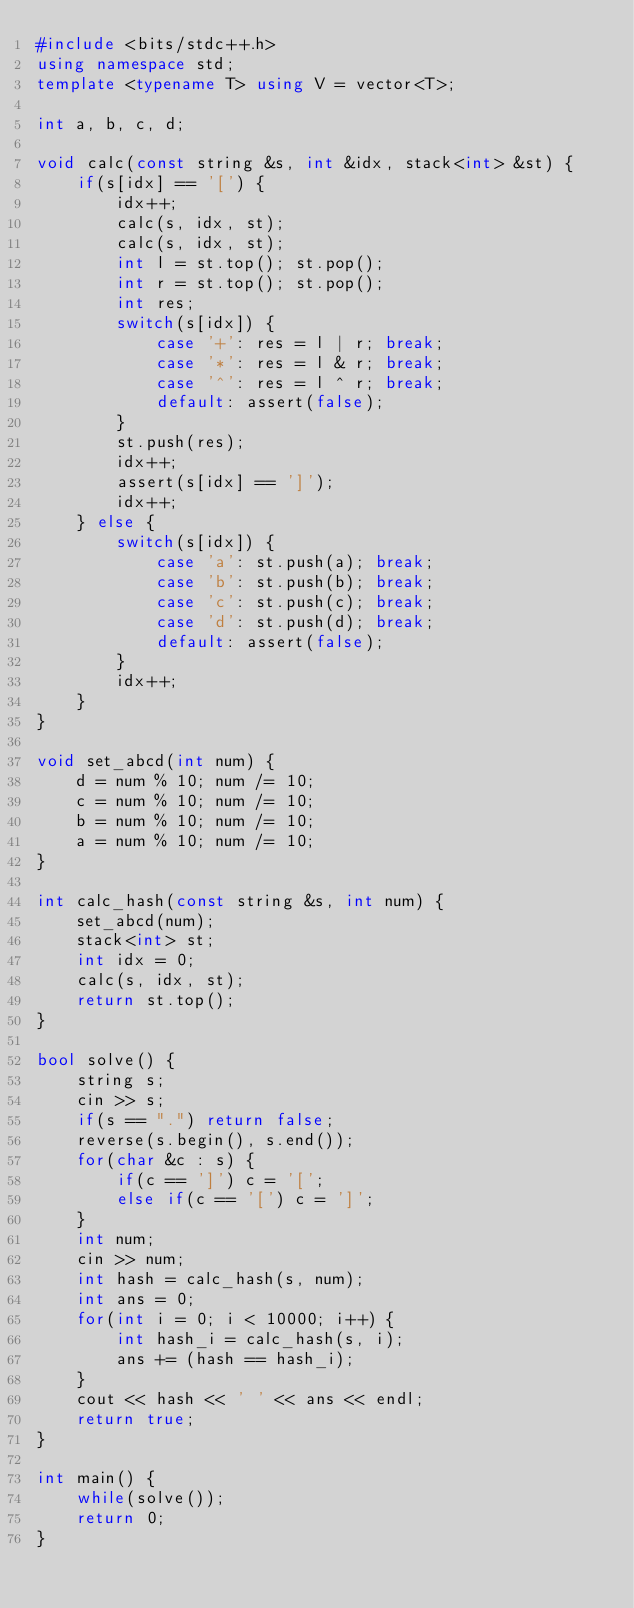Convert code to text. <code><loc_0><loc_0><loc_500><loc_500><_C++_>#include <bits/stdc++.h>
using namespace std;
template <typename T> using V = vector<T>;

int a, b, c, d;

void calc(const string &s, int &idx, stack<int> &st) {
    if(s[idx] == '[') {
        idx++;
        calc(s, idx, st);
        calc(s, idx, st);
        int l = st.top(); st.pop();
        int r = st.top(); st.pop();
        int res;
        switch(s[idx]) {
            case '+': res = l | r; break;
            case '*': res = l & r; break;
            case '^': res = l ^ r; break;
            default: assert(false);
        }
        st.push(res);
        idx++;
        assert(s[idx] == ']');
        idx++;
    } else {
        switch(s[idx]) {
            case 'a': st.push(a); break;
            case 'b': st.push(b); break;
            case 'c': st.push(c); break;
            case 'd': st.push(d); break;
            default: assert(false);
        }
        idx++;
    }
}

void set_abcd(int num) {
    d = num % 10; num /= 10;
    c = num % 10; num /= 10;
    b = num % 10; num /= 10;
    a = num % 10; num /= 10;
}

int calc_hash(const string &s, int num) {
    set_abcd(num);
    stack<int> st;
    int idx = 0;
    calc(s, idx, st);
    return st.top();
}

bool solve() {
    string s;
    cin >> s;
    if(s == ".") return false;
    reverse(s.begin(), s.end());
    for(char &c : s) {
        if(c == ']') c = '[';
        else if(c == '[') c = ']';
    }
    int num;
    cin >> num;
    int hash = calc_hash(s, num);
    int ans = 0;
    for(int i = 0; i < 10000; i++) {
        int hash_i = calc_hash(s, i);
        ans += (hash == hash_i);
    }
    cout << hash << ' ' << ans << endl;
    return true;
}

int main() {
    while(solve());
    return 0;
}

</code> 